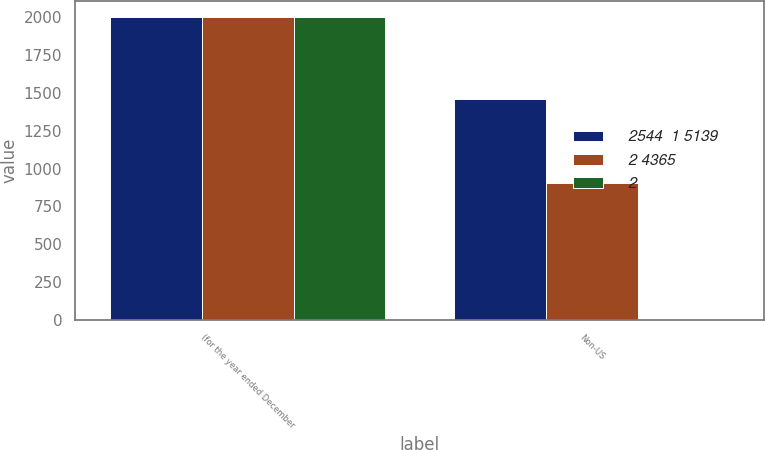<chart> <loc_0><loc_0><loc_500><loc_500><stacked_bar_chart><ecel><fcel>(for the year ended December<fcel>Non-US<nl><fcel>2544  1 5139<fcel>2005<fcel>1457<nl><fcel>2 4365<fcel>2004<fcel>904<nl><fcel>2<fcel>2003<fcel>6<nl></chart> 